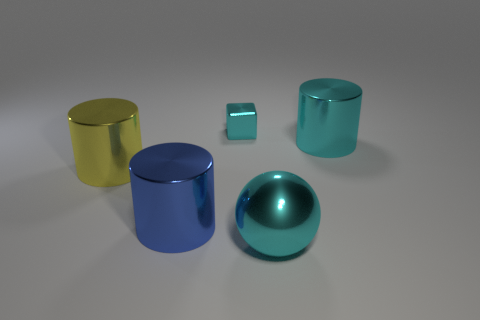How many other objects are there of the same size as the cyan cylinder?
Offer a very short reply. 3. What material is the big cyan sphere?
Give a very brief answer. Metal. Is the number of big yellow metal cylinders to the left of the cyan shiny cylinder greater than the number of yellow rubber cylinders?
Keep it short and to the point. Yes. Are any rubber cylinders visible?
Offer a very short reply. No. What number of other things are there of the same shape as the small cyan shiny object?
Your answer should be very brief. 0. Do the big shiny thing on the right side of the big ball and the large cylinder that is to the left of the large blue object have the same color?
Offer a terse response. No. How big is the cylinder on the right side of the object behind the large cylinder on the right side of the cyan cube?
Offer a very short reply. Large. There is a metallic object that is in front of the small cyan metal object and behind the big yellow thing; what is its shape?
Offer a very short reply. Cylinder. Are there an equal number of cyan metal cubes that are to the right of the tiny cube and metallic cylinders in front of the cyan shiny ball?
Keep it short and to the point. Yes. Is there a yellow thing that has the same material as the big blue cylinder?
Give a very brief answer. Yes. 